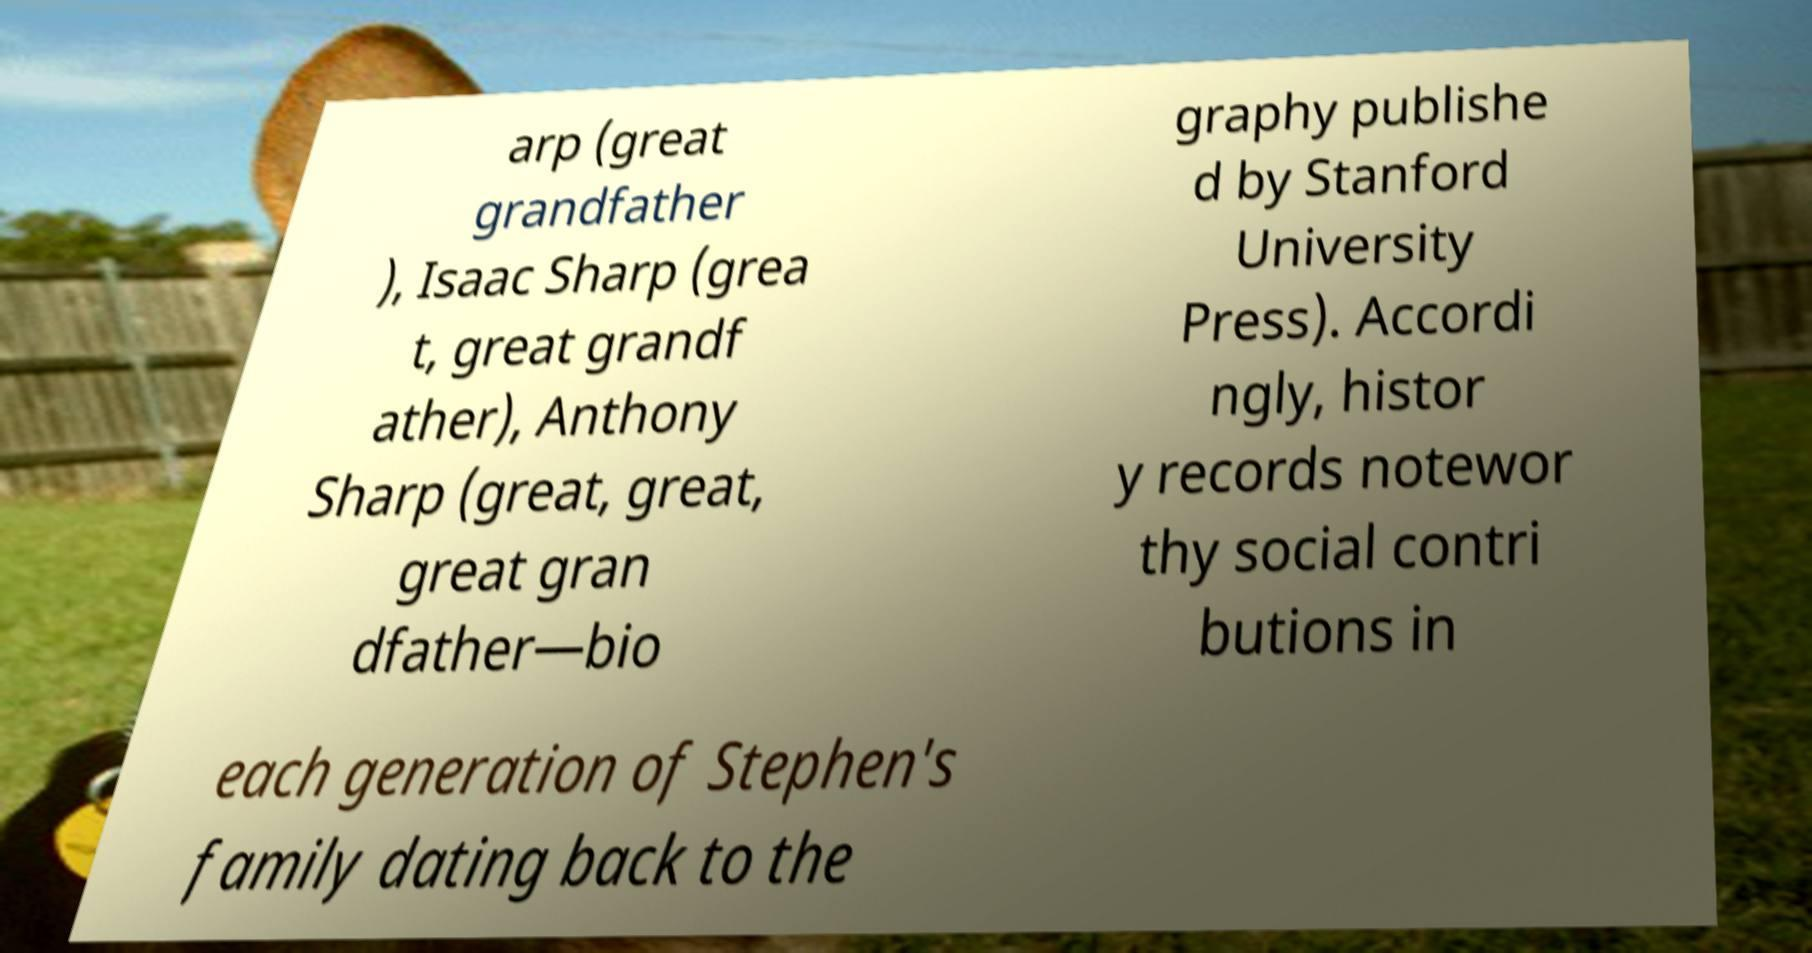Could you assist in decoding the text presented in this image and type it out clearly? arp (great grandfather ), Isaac Sharp (grea t, great grandf ather), Anthony Sharp (great, great, great gran dfather—bio graphy publishe d by Stanford University Press). Accordi ngly, histor y records notewor thy social contri butions in each generation of Stephen's family dating back to the 